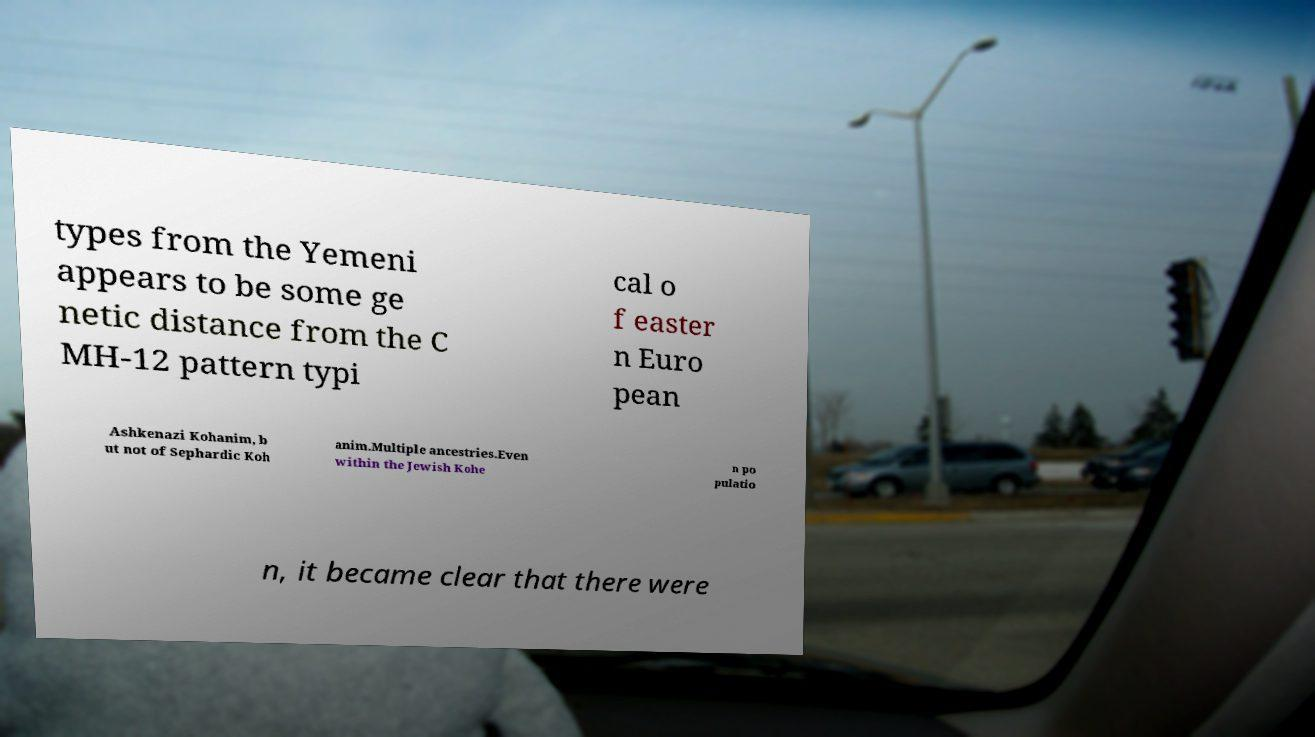For documentation purposes, I need the text within this image transcribed. Could you provide that? types from the Yemeni appears to be some ge netic distance from the C MH-12 pattern typi cal o f easter n Euro pean Ashkenazi Kohanim, b ut not of Sephardic Koh anim.Multiple ancestries.Even within the Jewish Kohe n po pulatio n, it became clear that there were 